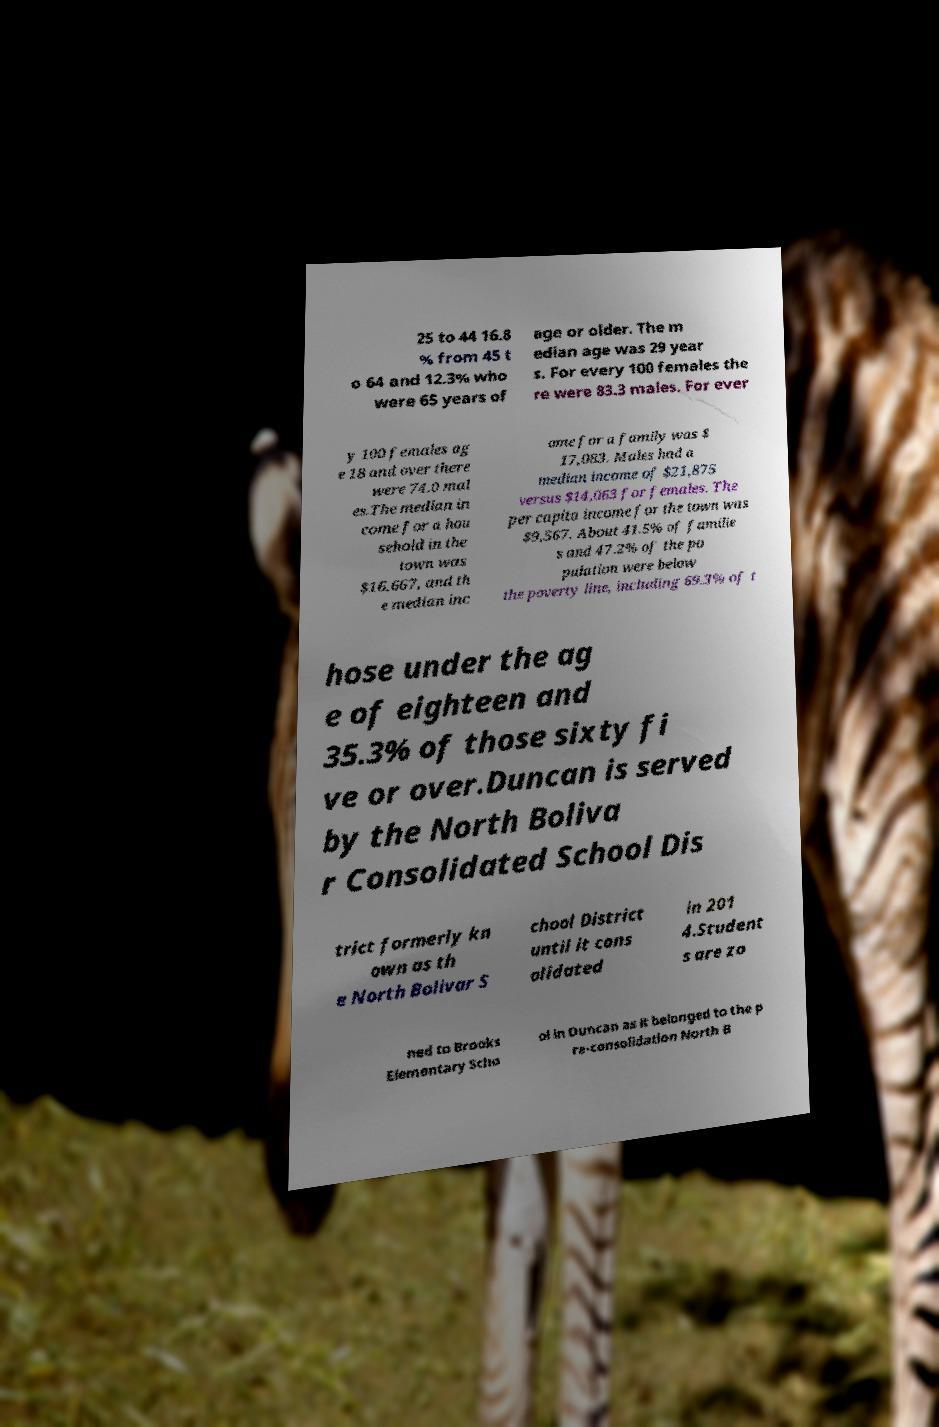There's text embedded in this image that I need extracted. Can you transcribe it verbatim? 25 to 44 16.8 % from 45 t o 64 and 12.3% who were 65 years of age or older. The m edian age was 29 year s. For every 100 females the re were 83.3 males. For ever y 100 females ag e 18 and over there were 74.0 mal es.The median in come for a hou sehold in the town was $16,667, and th e median inc ome for a family was $ 17,083. Males had a median income of $21,875 versus $14,063 for females. The per capita income for the town was $9,567. About 41.5% of familie s and 47.2% of the po pulation were below the poverty line, including 69.3% of t hose under the ag e of eighteen and 35.3% of those sixty fi ve or over.Duncan is served by the North Boliva r Consolidated School Dis trict formerly kn own as th e North Bolivar S chool District until it cons olidated in 201 4.Student s are zo ned to Brooks Elementary Scho ol in Duncan as it belonged to the p re-consolidation North B 